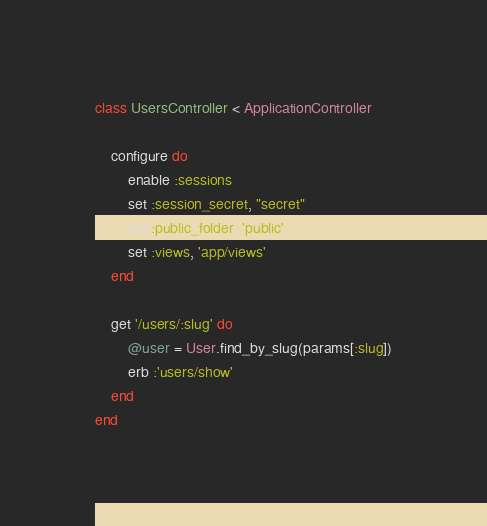Convert code to text. <code><loc_0><loc_0><loc_500><loc_500><_Ruby_>class UsersController < ApplicationController
    
    configure do
        enable :sessions
        set :session_secret, "secret"
        set :public_folder, 'public'
        set :views, 'app/views'
    end

    get '/users/:slug' do
        @user = User.find_by_slug(params[:slug])
        erb :'users/show'
    end
end
</code> 